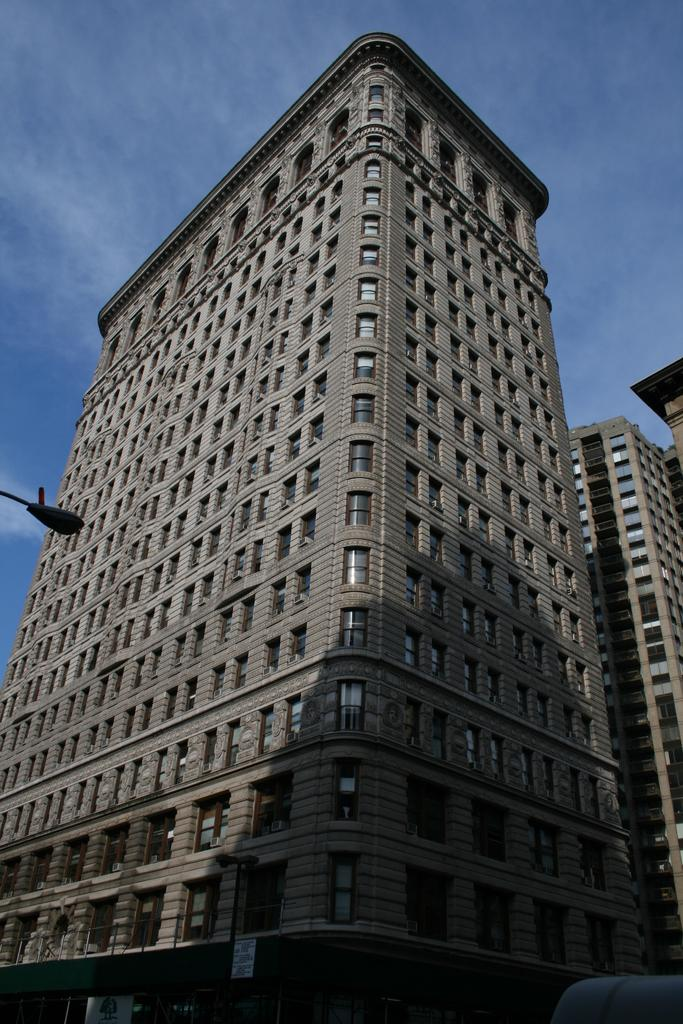What type of structures can be seen in the image? There are buildings with windows in the image. What other objects can be seen on the street in the image? There are street poles in the image. Is there any text or information displayed in the image? Yes, there is a signboard in the image. What is visible in the background of the image? The sky is visible in the image. How would you describe the weather based on the sky in the image? The sky appears to be cloudy in the image. What month is it in the image? The image does not provide any information about the month; it only shows buildings, street poles, a signboard, and a cloudy sky. 